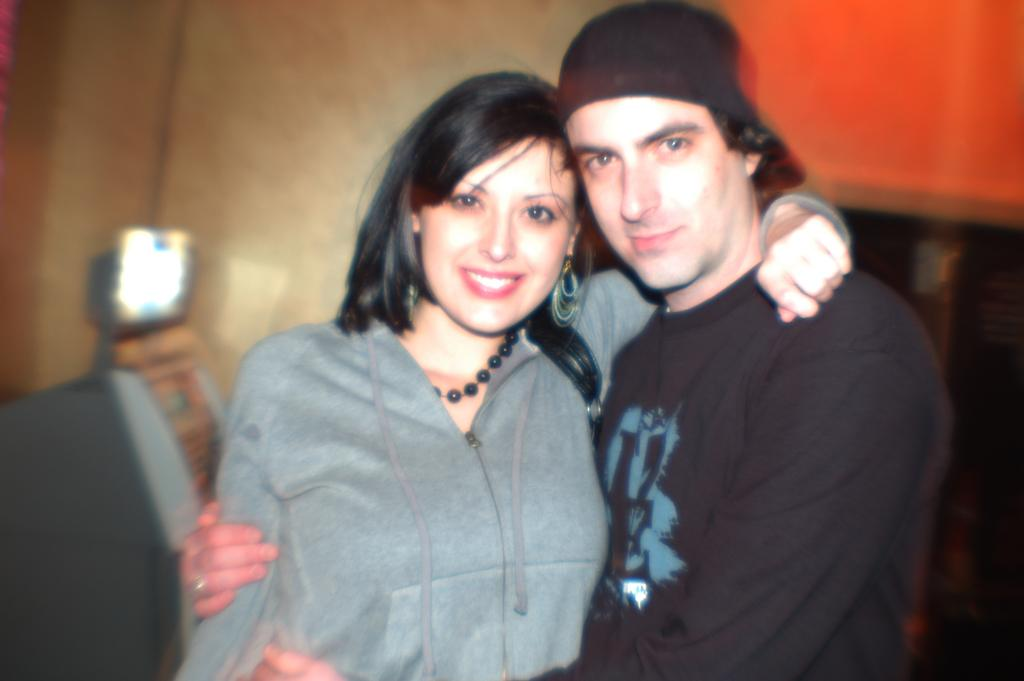How many people are in the image? There is a man and a woman in the image. What are the people in the image doing? Both the man and the woman are standing and smiling. What can be seen in the background of the image? There is a wall and other objects in the background of the image. How is the background of the image depicted? The background of the image is blurred. Where is the nearest airport to the location of the image? The provided facts do not mention an airport or its location, so it cannot be determined from the image. 